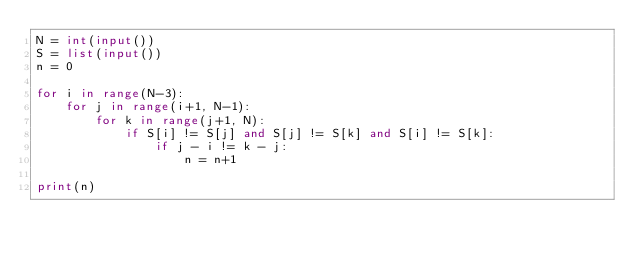<code> <loc_0><loc_0><loc_500><loc_500><_Python_>N = int(input())
S = list(input())
n = 0

for i in range(N-3):
    for j in range(i+1, N-1):
        for k in range(j+1, N):
            if S[i] != S[j] and S[j] != S[k] and S[i] != S[k]:
                if j - i != k - j:
                    n = n+1

print(n)</code> 